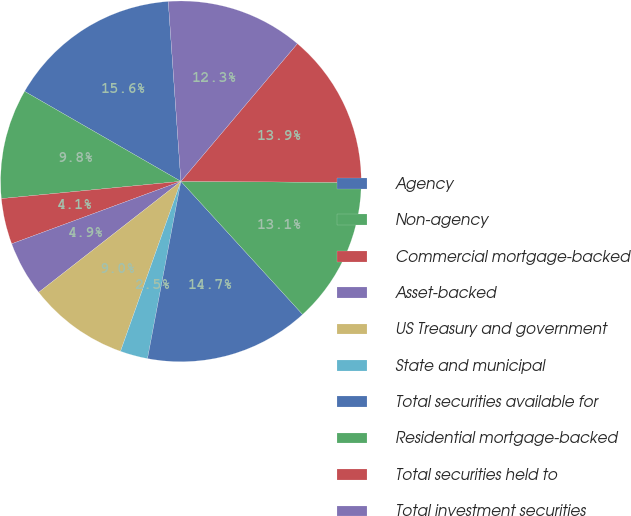Convert chart to OTSL. <chart><loc_0><loc_0><loc_500><loc_500><pie_chart><fcel>Agency<fcel>Non-agency<fcel>Commercial mortgage-backed<fcel>Asset-backed<fcel>US Treasury and government<fcel>State and municipal<fcel>Total securities available for<fcel>Residential mortgage-backed<fcel>Total securities held to<fcel>Total investment securities<nl><fcel>15.57%<fcel>9.84%<fcel>4.1%<fcel>4.92%<fcel>9.02%<fcel>2.47%<fcel>14.75%<fcel>13.11%<fcel>13.93%<fcel>12.29%<nl></chart> 